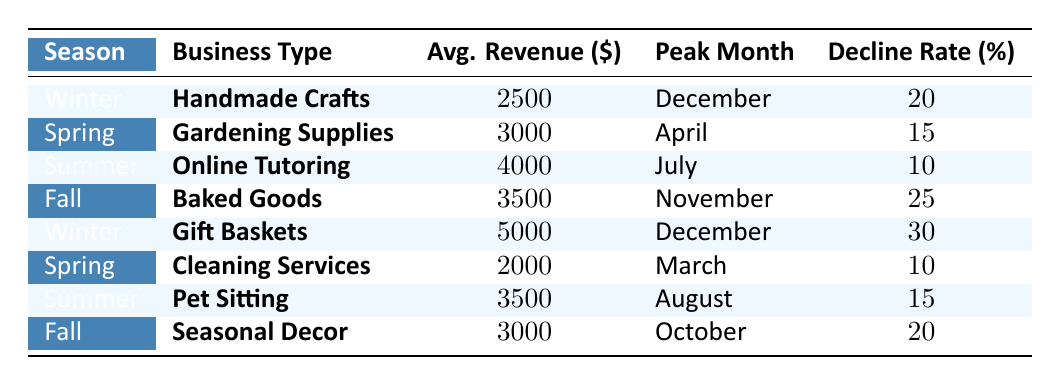What is the average revenue for the "Online Tutoring" business type? The revenue for "Online Tutoring" is listed as 4000 in the table. Therefore, the average revenue for this business type is simply 4000.
Answer: 4000 Which business type has the highest average revenue in winter? In the winter season, there are two business types listed: "Handmade Crafts" with average revenue 2500 and "Gift Baskets" with average revenue 5000. Comparing these values, "Gift Baskets" has the highest average revenue.
Answer: Gift Baskets What is the decline rate for "Seasonal Decor"? The decline rate for "Seasonal Decor" is stated as 20% in the table. This value is taken directly from the corresponding row for this business type.
Answer: 20 In which season do "Gardening Supplies" have their peak month? "Gardening Supplies" have their peak month in April, which falls under the Spring season as indicated in the data.
Answer: Spring What is the total average revenue of all businesses listed in the table? To find the total average revenue, we sum the average revenues provided: 2500 (Handmade Crafts) + 3000 (Gardening Supplies) + 4000 (Online Tutoring) + 3500 (Baked Goods) + 5000 (Gift Baskets) + 2000 (Cleaning Services) + 3500 (Pet Sitting) + 3000 (Seasonal Decor) = 29500. This total is then confirmed as the result. To get the average, we divide by the number of business types, which is 8: 29500 / 8 = 3687.5.
Answer: 3687.5 Does the "Pet Sitting" business have a lower decline rate than "Baked Goods"? The decline rate for "Pet Sitting" is 15%, while the decline rate for "Baked Goods" is 25%. Since 15% is less than 25%, it confirms that "Pet Sitting" has a lower decline rate than "Baked Goods".
Answer: Yes What is the peak month for the highest average revenue business type? The highest average revenue is 5000 from "Gift Baskets". Its peak month, as per the data, is December. Therefore, we can conclude that December is the peak month for the highest revenue business.
Answer: December Which season has the lowest average revenue across all its business types? The average revenues per season are: Winter (2500 + 5000 = 3750), Spring (3000 + 2000 = 2500), Summer (4000 + 3500 = 3750), and Fall (3500 + 3000 = 3250). The lowest average revenue is thus found in Spring, with a total average of 2500.
Answer: Spring What business types see an increase in revenue during the summer compared to the winter? "Online Tutoring" makes 4000 in the summer, which is higher than "Handmade Crafts" at 2500, and "Gift Baskets" at 5000 shows an increase in the summer months as well. "Pet Sitting" in summer generates 3500. However, "Handmade Crafts" in winter only brings in 2500. Therefore, both "Online Tutoring" and "Pet Sitting" see an increase in revenue when comparing summer to winter.
Answer: Online Tutoring and Pet Sitting 